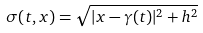Convert formula to latex. <formula><loc_0><loc_0><loc_500><loc_500>\sigma ( t , x ) = \sqrt { | x - \gamma ( t ) | ^ { 2 } + h ^ { 2 } }</formula> 